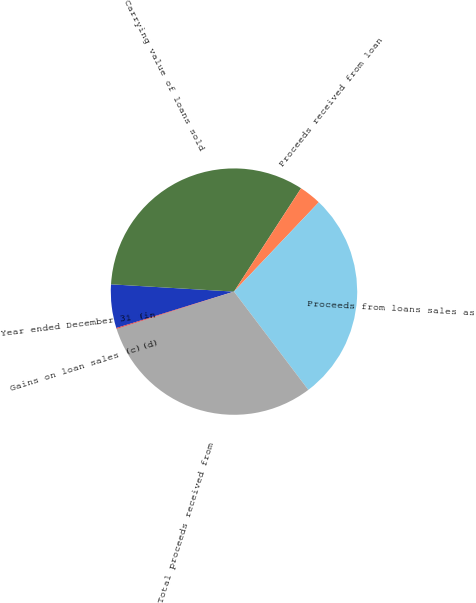Convert chart. <chart><loc_0><loc_0><loc_500><loc_500><pie_chart><fcel>Year ended December 31 (in<fcel>Carrying value of loans sold<fcel>Proceeds received from loan<fcel>Proceeds from loans sales as<fcel>Total proceeds received from<fcel>Gains on loan sales (c)(d)<nl><fcel>5.72%<fcel>33.22%<fcel>2.92%<fcel>27.61%<fcel>30.41%<fcel>0.12%<nl></chart> 